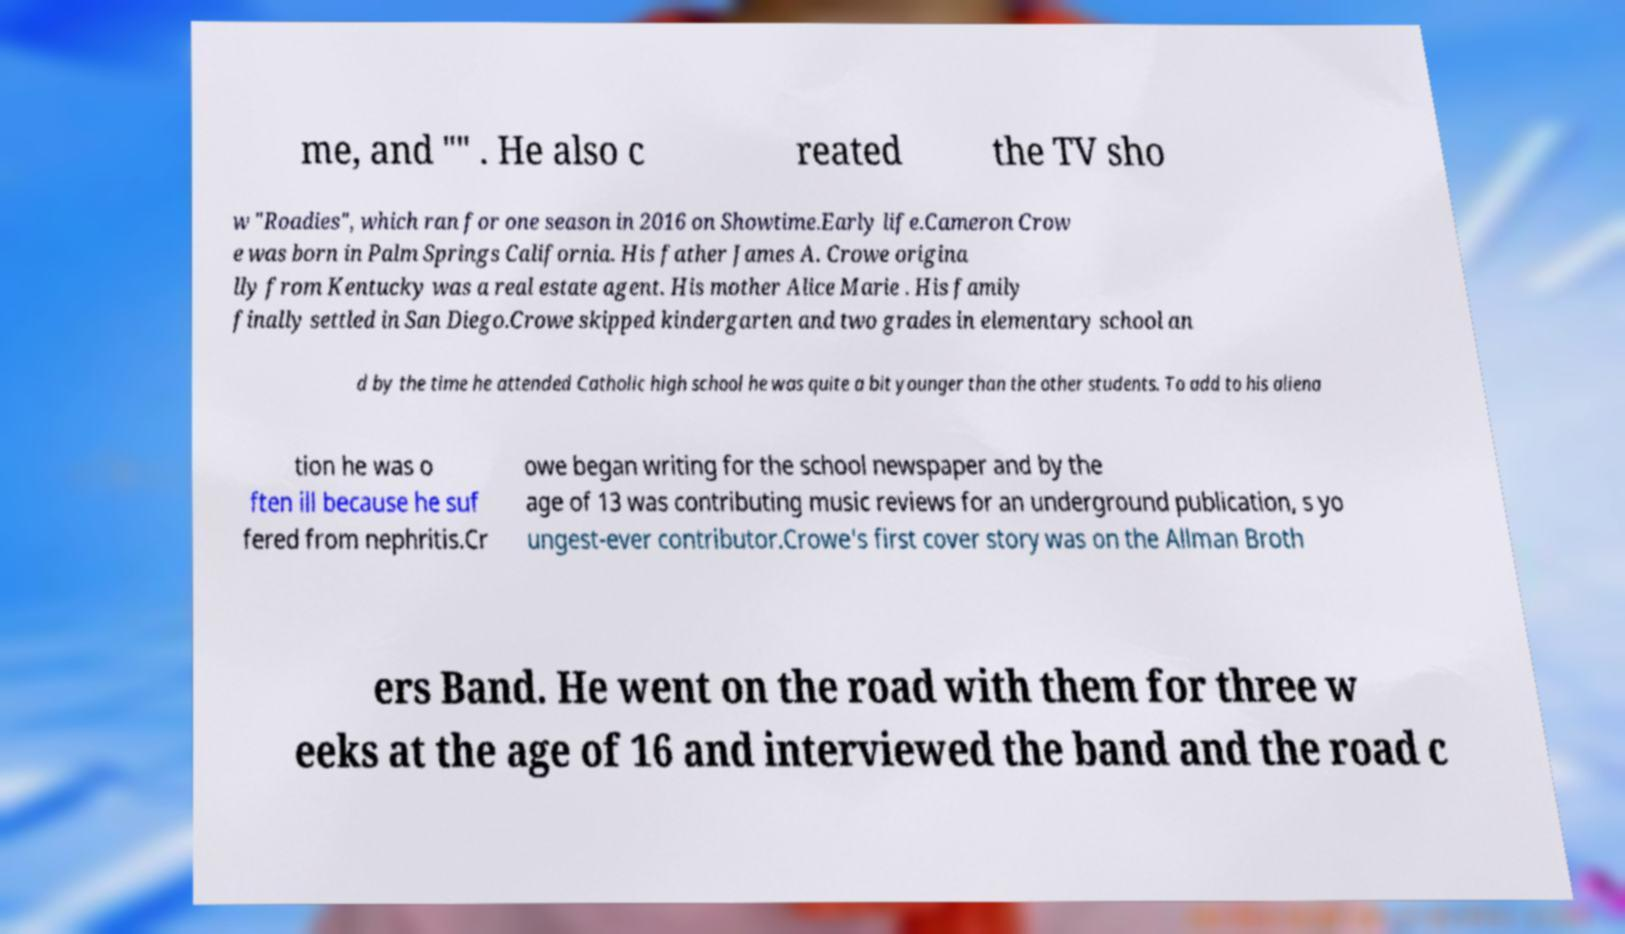I need the written content from this picture converted into text. Can you do that? me, and "" . He also c reated the TV sho w "Roadies", which ran for one season in 2016 on Showtime.Early life.Cameron Crow e was born in Palm Springs California. His father James A. Crowe origina lly from Kentucky was a real estate agent. His mother Alice Marie . His family finally settled in San Diego.Crowe skipped kindergarten and two grades in elementary school an d by the time he attended Catholic high school he was quite a bit younger than the other students. To add to his aliena tion he was o ften ill because he suf fered from nephritis.Cr owe began writing for the school newspaper and by the age of 13 was contributing music reviews for an underground publication, s yo ungest-ever contributor.Crowe's first cover story was on the Allman Broth ers Band. He went on the road with them for three w eeks at the age of 16 and interviewed the band and the road c 